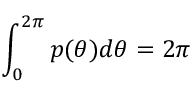Convert formula to latex. <formula><loc_0><loc_0><loc_500><loc_500>\int _ { 0 } ^ { 2 \pi } p ( \theta ) d \theta = 2 \pi</formula> 